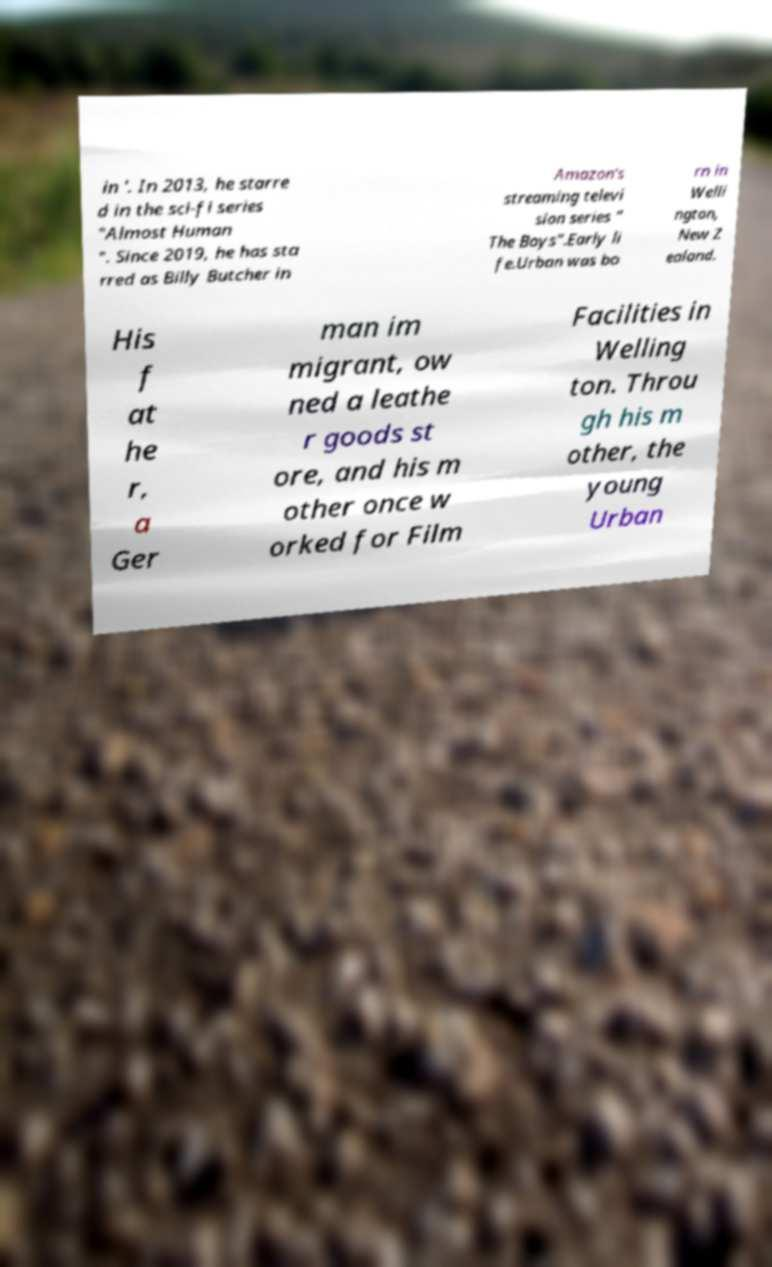Can you read and provide the text displayed in the image?This photo seems to have some interesting text. Can you extract and type it out for me? in '. In 2013, he starre d in the sci-fi series "Almost Human ". Since 2019, he has sta rred as Billy Butcher in Amazon's streaming televi sion series " The Boys".Early li fe.Urban was bo rn in Welli ngton, New Z ealand. His f at he r, a Ger man im migrant, ow ned a leathe r goods st ore, and his m other once w orked for Film Facilities in Welling ton. Throu gh his m other, the young Urban 